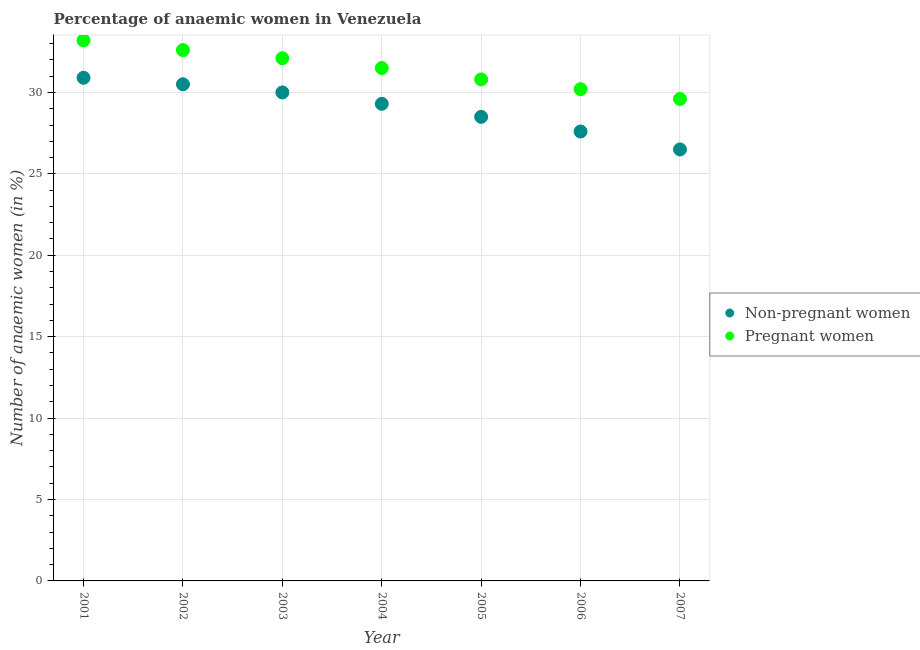What is the percentage of non-pregnant anaemic women in 2005?
Your answer should be very brief. 28.5. Across all years, what is the maximum percentage of pregnant anaemic women?
Offer a terse response. 33.2. Across all years, what is the minimum percentage of pregnant anaemic women?
Provide a short and direct response. 29.6. In which year was the percentage of pregnant anaemic women maximum?
Your answer should be very brief. 2001. In which year was the percentage of pregnant anaemic women minimum?
Give a very brief answer. 2007. What is the total percentage of non-pregnant anaemic women in the graph?
Provide a succinct answer. 203.3. What is the difference between the percentage of pregnant anaemic women in 2001 and that in 2003?
Make the answer very short. 1.1. What is the difference between the percentage of non-pregnant anaemic women in 2007 and the percentage of pregnant anaemic women in 2001?
Give a very brief answer. -6.7. What is the average percentage of non-pregnant anaemic women per year?
Your response must be concise. 29.04. In the year 2004, what is the difference between the percentage of pregnant anaemic women and percentage of non-pregnant anaemic women?
Your answer should be compact. 2.2. What is the ratio of the percentage of pregnant anaemic women in 2001 to that in 2003?
Your answer should be compact. 1.03. Is the percentage of non-pregnant anaemic women in 2005 less than that in 2006?
Your answer should be compact. No. What is the difference between the highest and the second highest percentage of pregnant anaemic women?
Make the answer very short. 0.6. What is the difference between the highest and the lowest percentage of pregnant anaemic women?
Provide a succinct answer. 3.6. In how many years, is the percentage of non-pregnant anaemic women greater than the average percentage of non-pregnant anaemic women taken over all years?
Your answer should be very brief. 4. Does the percentage of non-pregnant anaemic women monotonically increase over the years?
Offer a terse response. No. How many dotlines are there?
Your answer should be very brief. 2. What is the difference between two consecutive major ticks on the Y-axis?
Your answer should be compact. 5. Are the values on the major ticks of Y-axis written in scientific E-notation?
Provide a succinct answer. No. Does the graph contain any zero values?
Offer a terse response. No. Does the graph contain grids?
Offer a terse response. Yes. Where does the legend appear in the graph?
Make the answer very short. Center right. How many legend labels are there?
Keep it short and to the point. 2. How are the legend labels stacked?
Make the answer very short. Vertical. What is the title of the graph?
Provide a short and direct response. Percentage of anaemic women in Venezuela. What is the label or title of the X-axis?
Your answer should be very brief. Year. What is the label or title of the Y-axis?
Provide a short and direct response. Number of anaemic women (in %). What is the Number of anaemic women (in %) in Non-pregnant women in 2001?
Offer a very short reply. 30.9. What is the Number of anaemic women (in %) of Pregnant women in 2001?
Offer a very short reply. 33.2. What is the Number of anaemic women (in %) of Non-pregnant women in 2002?
Give a very brief answer. 30.5. What is the Number of anaemic women (in %) of Pregnant women in 2002?
Provide a succinct answer. 32.6. What is the Number of anaemic women (in %) of Pregnant women in 2003?
Your answer should be compact. 32.1. What is the Number of anaemic women (in %) in Non-pregnant women in 2004?
Your response must be concise. 29.3. What is the Number of anaemic women (in %) in Pregnant women in 2004?
Keep it short and to the point. 31.5. What is the Number of anaemic women (in %) of Pregnant women in 2005?
Make the answer very short. 30.8. What is the Number of anaemic women (in %) of Non-pregnant women in 2006?
Provide a succinct answer. 27.6. What is the Number of anaemic women (in %) of Pregnant women in 2006?
Provide a succinct answer. 30.2. What is the Number of anaemic women (in %) in Pregnant women in 2007?
Your response must be concise. 29.6. Across all years, what is the maximum Number of anaemic women (in %) of Non-pregnant women?
Give a very brief answer. 30.9. Across all years, what is the maximum Number of anaemic women (in %) in Pregnant women?
Offer a very short reply. 33.2. Across all years, what is the minimum Number of anaemic women (in %) of Pregnant women?
Provide a short and direct response. 29.6. What is the total Number of anaemic women (in %) of Non-pregnant women in the graph?
Offer a very short reply. 203.3. What is the total Number of anaemic women (in %) of Pregnant women in the graph?
Ensure brevity in your answer.  220. What is the difference between the Number of anaemic women (in %) of Non-pregnant women in 2001 and that in 2002?
Provide a succinct answer. 0.4. What is the difference between the Number of anaemic women (in %) of Pregnant women in 2001 and that in 2002?
Provide a short and direct response. 0.6. What is the difference between the Number of anaemic women (in %) of Non-pregnant women in 2001 and that in 2004?
Your answer should be compact. 1.6. What is the difference between the Number of anaemic women (in %) in Pregnant women in 2001 and that in 2004?
Offer a very short reply. 1.7. What is the difference between the Number of anaemic women (in %) of Pregnant women in 2001 and that in 2007?
Ensure brevity in your answer.  3.6. What is the difference between the Number of anaemic women (in %) of Non-pregnant women in 2003 and that in 2005?
Your answer should be very brief. 1.5. What is the difference between the Number of anaemic women (in %) in Pregnant women in 2003 and that in 2006?
Your answer should be very brief. 1.9. What is the difference between the Number of anaemic women (in %) in Non-pregnant women in 2003 and that in 2007?
Make the answer very short. 3.5. What is the difference between the Number of anaemic women (in %) of Non-pregnant women in 2004 and that in 2005?
Your answer should be very brief. 0.8. What is the difference between the Number of anaemic women (in %) of Pregnant women in 2004 and that in 2005?
Provide a succinct answer. 0.7. What is the difference between the Number of anaemic women (in %) in Pregnant women in 2004 and that in 2007?
Keep it short and to the point. 1.9. What is the difference between the Number of anaemic women (in %) in Non-pregnant women in 2005 and that in 2007?
Ensure brevity in your answer.  2. What is the difference between the Number of anaemic women (in %) in Pregnant women in 2005 and that in 2007?
Offer a terse response. 1.2. What is the difference between the Number of anaemic women (in %) in Non-pregnant women in 2006 and that in 2007?
Make the answer very short. 1.1. What is the difference between the Number of anaemic women (in %) of Non-pregnant women in 2001 and the Number of anaemic women (in %) of Pregnant women in 2002?
Your answer should be very brief. -1.7. What is the difference between the Number of anaemic women (in %) of Non-pregnant women in 2001 and the Number of anaemic women (in %) of Pregnant women in 2004?
Give a very brief answer. -0.6. What is the difference between the Number of anaemic women (in %) in Non-pregnant women in 2001 and the Number of anaemic women (in %) in Pregnant women in 2005?
Keep it short and to the point. 0.1. What is the difference between the Number of anaemic women (in %) of Non-pregnant women in 2002 and the Number of anaemic women (in %) of Pregnant women in 2003?
Your answer should be compact. -1.6. What is the difference between the Number of anaemic women (in %) in Non-pregnant women in 2002 and the Number of anaemic women (in %) in Pregnant women in 2005?
Your answer should be compact. -0.3. What is the difference between the Number of anaemic women (in %) of Non-pregnant women in 2002 and the Number of anaemic women (in %) of Pregnant women in 2007?
Offer a very short reply. 0.9. What is the difference between the Number of anaemic women (in %) in Non-pregnant women in 2003 and the Number of anaemic women (in %) in Pregnant women in 2005?
Make the answer very short. -0.8. What is the difference between the Number of anaemic women (in %) in Non-pregnant women in 2003 and the Number of anaemic women (in %) in Pregnant women in 2006?
Your answer should be compact. -0.2. What is the difference between the Number of anaemic women (in %) of Non-pregnant women in 2003 and the Number of anaemic women (in %) of Pregnant women in 2007?
Make the answer very short. 0.4. What is the difference between the Number of anaemic women (in %) in Non-pregnant women in 2004 and the Number of anaemic women (in %) in Pregnant women in 2005?
Give a very brief answer. -1.5. What is the difference between the Number of anaemic women (in %) in Non-pregnant women in 2004 and the Number of anaemic women (in %) in Pregnant women in 2006?
Keep it short and to the point. -0.9. What is the difference between the Number of anaemic women (in %) in Non-pregnant women in 2004 and the Number of anaemic women (in %) in Pregnant women in 2007?
Keep it short and to the point. -0.3. What is the difference between the Number of anaemic women (in %) in Non-pregnant women in 2006 and the Number of anaemic women (in %) in Pregnant women in 2007?
Make the answer very short. -2. What is the average Number of anaemic women (in %) in Non-pregnant women per year?
Ensure brevity in your answer.  29.04. What is the average Number of anaemic women (in %) in Pregnant women per year?
Offer a very short reply. 31.43. In the year 2003, what is the difference between the Number of anaemic women (in %) in Non-pregnant women and Number of anaemic women (in %) in Pregnant women?
Your answer should be very brief. -2.1. In the year 2006, what is the difference between the Number of anaemic women (in %) in Non-pregnant women and Number of anaemic women (in %) in Pregnant women?
Give a very brief answer. -2.6. What is the ratio of the Number of anaemic women (in %) in Non-pregnant women in 2001 to that in 2002?
Keep it short and to the point. 1.01. What is the ratio of the Number of anaemic women (in %) in Pregnant women in 2001 to that in 2002?
Your answer should be very brief. 1.02. What is the ratio of the Number of anaemic women (in %) of Pregnant women in 2001 to that in 2003?
Your response must be concise. 1.03. What is the ratio of the Number of anaemic women (in %) in Non-pregnant women in 2001 to that in 2004?
Offer a very short reply. 1.05. What is the ratio of the Number of anaemic women (in %) of Pregnant women in 2001 to that in 2004?
Your answer should be compact. 1.05. What is the ratio of the Number of anaemic women (in %) of Non-pregnant women in 2001 to that in 2005?
Make the answer very short. 1.08. What is the ratio of the Number of anaemic women (in %) in Pregnant women in 2001 to that in 2005?
Give a very brief answer. 1.08. What is the ratio of the Number of anaemic women (in %) in Non-pregnant women in 2001 to that in 2006?
Offer a very short reply. 1.12. What is the ratio of the Number of anaemic women (in %) in Pregnant women in 2001 to that in 2006?
Give a very brief answer. 1.1. What is the ratio of the Number of anaemic women (in %) in Non-pregnant women in 2001 to that in 2007?
Provide a succinct answer. 1.17. What is the ratio of the Number of anaemic women (in %) in Pregnant women in 2001 to that in 2007?
Make the answer very short. 1.12. What is the ratio of the Number of anaemic women (in %) of Non-pregnant women in 2002 to that in 2003?
Offer a very short reply. 1.02. What is the ratio of the Number of anaemic women (in %) of Pregnant women in 2002 to that in 2003?
Your response must be concise. 1.02. What is the ratio of the Number of anaemic women (in %) of Non-pregnant women in 2002 to that in 2004?
Provide a short and direct response. 1.04. What is the ratio of the Number of anaemic women (in %) in Pregnant women in 2002 to that in 2004?
Keep it short and to the point. 1.03. What is the ratio of the Number of anaemic women (in %) in Non-pregnant women in 2002 to that in 2005?
Provide a short and direct response. 1.07. What is the ratio of the Number of anaemic women (in %) of Pregnant women in 2002 to that in 2005?
Ensure brevity in your answer.  1.06. What is the ratio of the Number of anaemic women (in %) of Non-pregnant women in 2002 to that in 2006?
Your answer should be compact. 1.11. What is the ratio of the Number of anaemic women (in %) of Pregnant women in 2002 to that in 2006?
Ensure brevity in your answer.  1.08. What is the ratio of the Number of anaemic women (in %) in Non-pregnant women in 2002 to that in 2007?
Ensure brevity in your answer.  1.15. What is the ratio of the Number of anaemic women (in %) of Pregnant women in 2002 to that in 2007?
Offer a very short reply. 1.1. What is the ratio of the Number of anaemic women (in %) of Non-pregnant women in 2003 to that in 2004?
Your answer should be compact. 1.02. What is the ratio of the Number of anaemic women (in %) in Non-pregnant women in 2003 to that in 2005?
Provide a short and direct response. 1.05. What is the ratio of the Number of anaemic women (in %) in Pregnant women in 2003 to that in 2005?
Give a very brief answer. 1.04. What is the ratio of the Number of anaemic women (in %) in Non-pregnant women in 2003 to that in 2006?
Offer a terse response. 1.09. What is the ratio of the Number of anaemic women (in %) of Pregnant women in 2003 to that in 2006?
Your response must be concise. 1.06. What is the ratio of the Number of anaemic women (in %) in Non-pregnant women in 2003 to that in 2007?
Your answer should be very brief. 1.13. What is the ratio of the Number of anaemic women (in %) of Pregnant women in 2003 to that in 2007?
Offer a very short reply. 1.08. What is the ratio of the Number of anaemic women (in %) in Non-pregnant women in 2004 to that in 2005?
Your answer should be very brief. 1.03. What is the ratio of the Number of anaemic women (in %) of Pregnant women in 2004 to that in 2005?
Your answer should be very brief. 1.02. What is the ratio of the Number of anaemic women (in %) of Non-pregnant women in 2004 to that in 2006?
Your response must be concise. 1.06. What is the ratio of the Number of anaemic women (in %) of Pregnant women in 2004 to that in 2006?
Offer a terse response. 1.04. What is the ratio of the Number of anaemic women (in %) of Non-pregnant women in 2004 to that in 2007?
Your response must be concise. 1.11. What is the ratio of the Number of anaemic women (in %) in Pregnant women in 2004 to that in 2007?
Your answer should be very brief. 1.06. What is the ratio of the Number of anaemic women (in %) in Non-pregnant women in 2005 to that in 2006?
Provide a short and direct response. 1.03. What is the ratio of the Number of anaemic women (in %) of Pregnant women in 2005 to that in 2006?
Your answer should be compact. 1.02. What is the ratio of the Number of anaemic women (in %) in Non-pregnant women in 2005 to that in 2007?
Give a very brief answer. 1.08. What is the ratio of the Number of anaemic women (in %) in Pregnant women in 2005 to that in 2007?
Ensure brevity in your answer.  1.04. What is the ratio of the Number of anaemic women (in %) in Non-pregnant women in 2006 to that in 2007?
Offer a very short reply. 1.04. What is the ratio of the Number of anaemic women (in %) in Pregnant women in 2006 to that in 2007?
Your response must be concise. 1.02. What is the difference between the highest and the second highest Number of anaemic women (in %) in Non-pregnant women?
Ensure brevity in your answer.  0.4. What is the difference between the highest and the lowest Number of anaemic women (in %) in Non-pregnant women?
Offer a very short reply. 4.4. What is the difference between the highest and the lowest Number of anaemic women (in %) of Pregnant women?
Give a very brief answer. 3.6. 